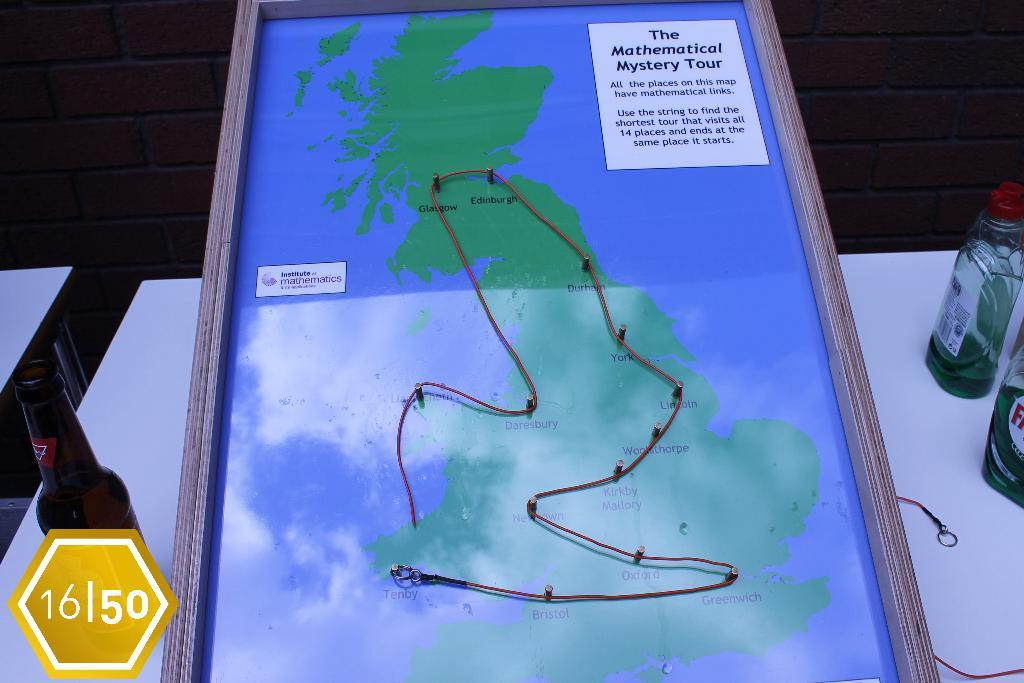<image>
Present a compact description of the photo's key features. Large map of a mystery tour that has trails marked on it 